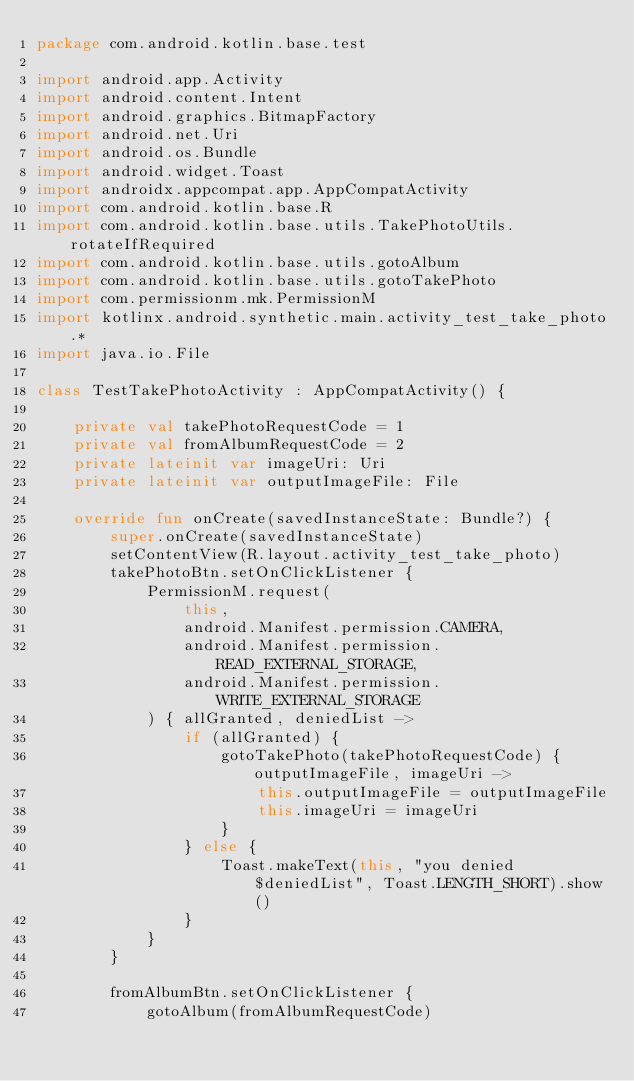Convert code to text. <code><loc_0><loc_0><loc_500><loc_500><_Kotlin_>package com.android.kotlin.base.test

import android.app.Activity
import android.content.Intent
import android.graphics.BitmapFactory
import android.net.Uri
import android.os.Bundle
import android.widget.Toast
import androidx.appcompat.app.AppCompatActivity
import com.android.kotlin.base.R
import com.android.kotlin.base.utils.TakePhotoUtils.rotateIfRequired
import com.android.kotlin.base.utils.gotoAlbum
import com.android.kotlin.base.utils.gotoTakePhoto
import com.permissionm.mk.PermissionM
import kotlinx.android.synthetic.main.activity_test_take_photo.*
import java.io.File

class TestTakePhotoActivity : AppCompatActivity() {

    private val takePhotoRequestCode = 1
    private val fromAlbumRequestCode = 2
    private lateinit var imageUri: Uri
    private lateinit var outputImageFile: File

    override fun onCreate(savedInstanceState: Bundle?) {
        super.onCreate(savedInstanceState)
        setContentView(R.layout.activity_test_take_photo)
        takePhotoBtn.setOnClickListener {
            PermissionM.request(
                this,
                android.Manifest.permission.CAMERA,
                android.Manifest.permission.READ_EXTERNAL_STORAGE,
                android.Manifest.permission.WRITE_EXTERNAL_STORAGE
            ) { allGranted, deniedList ->
                if (allGranted) {
                    gotoTakePhoto(takePhotoRequestCode) { outputImageFile, imageUri ->
                        this.outputImageFile = outputImageFile
                        this.imageUri = imageUri
                    }
                } else {
                    Toast.makeText(this, "you denied $deniedList", Toast.LENGTH_SHORT).show()
                }
            }
        }

        fromAlbumBtn.setOnClickListener {
            gotoAlbum(fromAlbumRequestCode)</code> 